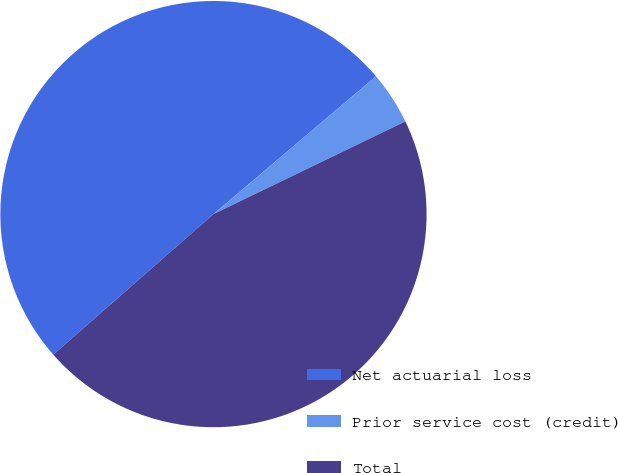Convert chart. <chart><loc_0><loc_0><loc_500><loc_500><pie_chart><fcel>Net actuarial loss<fcel>Prior service cost (credit)<fcel>Total<nl><fcel>50.27%<fcel>4.03%<fcel>45.7%<nl></chart> 